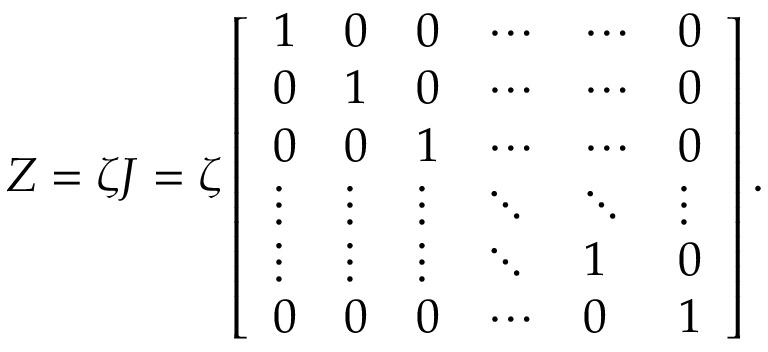Convert formula to latex. <formula><loc_0><loc_0><loc_500><loc_500>Z = \zeta J = \zeta \left [ \begin{array} { l l l l l l } { 1 } & { 0 } & { 0 } & { \cdots } & { \cdots } & { 0 } \\ { 0 } & { 1 } & { 0 } & { \cdots } & { \cdots } & { 0 } \\ { 0 } & { 0 } & { 1 } & { \cdots } & { \cdots } & { 0 } \\ { \vdots } & { \vdots } & { \vdots } & { \ddots } & { \ddots } & { \vdots } \\ { \vdots } & { \vdots } & { \vdots } & { \ddots } & { 1 } & { 0 } \\ { 0 } & { 0 } & { 0 } & { \cdots } & { 0 } & { 1 } \end{array} \right ] .</formula> 